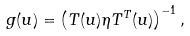Convert formula to latex. <formula><loc_0><loc_0><loc_500><loc_500>g ( u ) = \left ( T ( u ) \eta T ^ { T } ( u ) \right ) ^ { - 1 } ,</formula> 